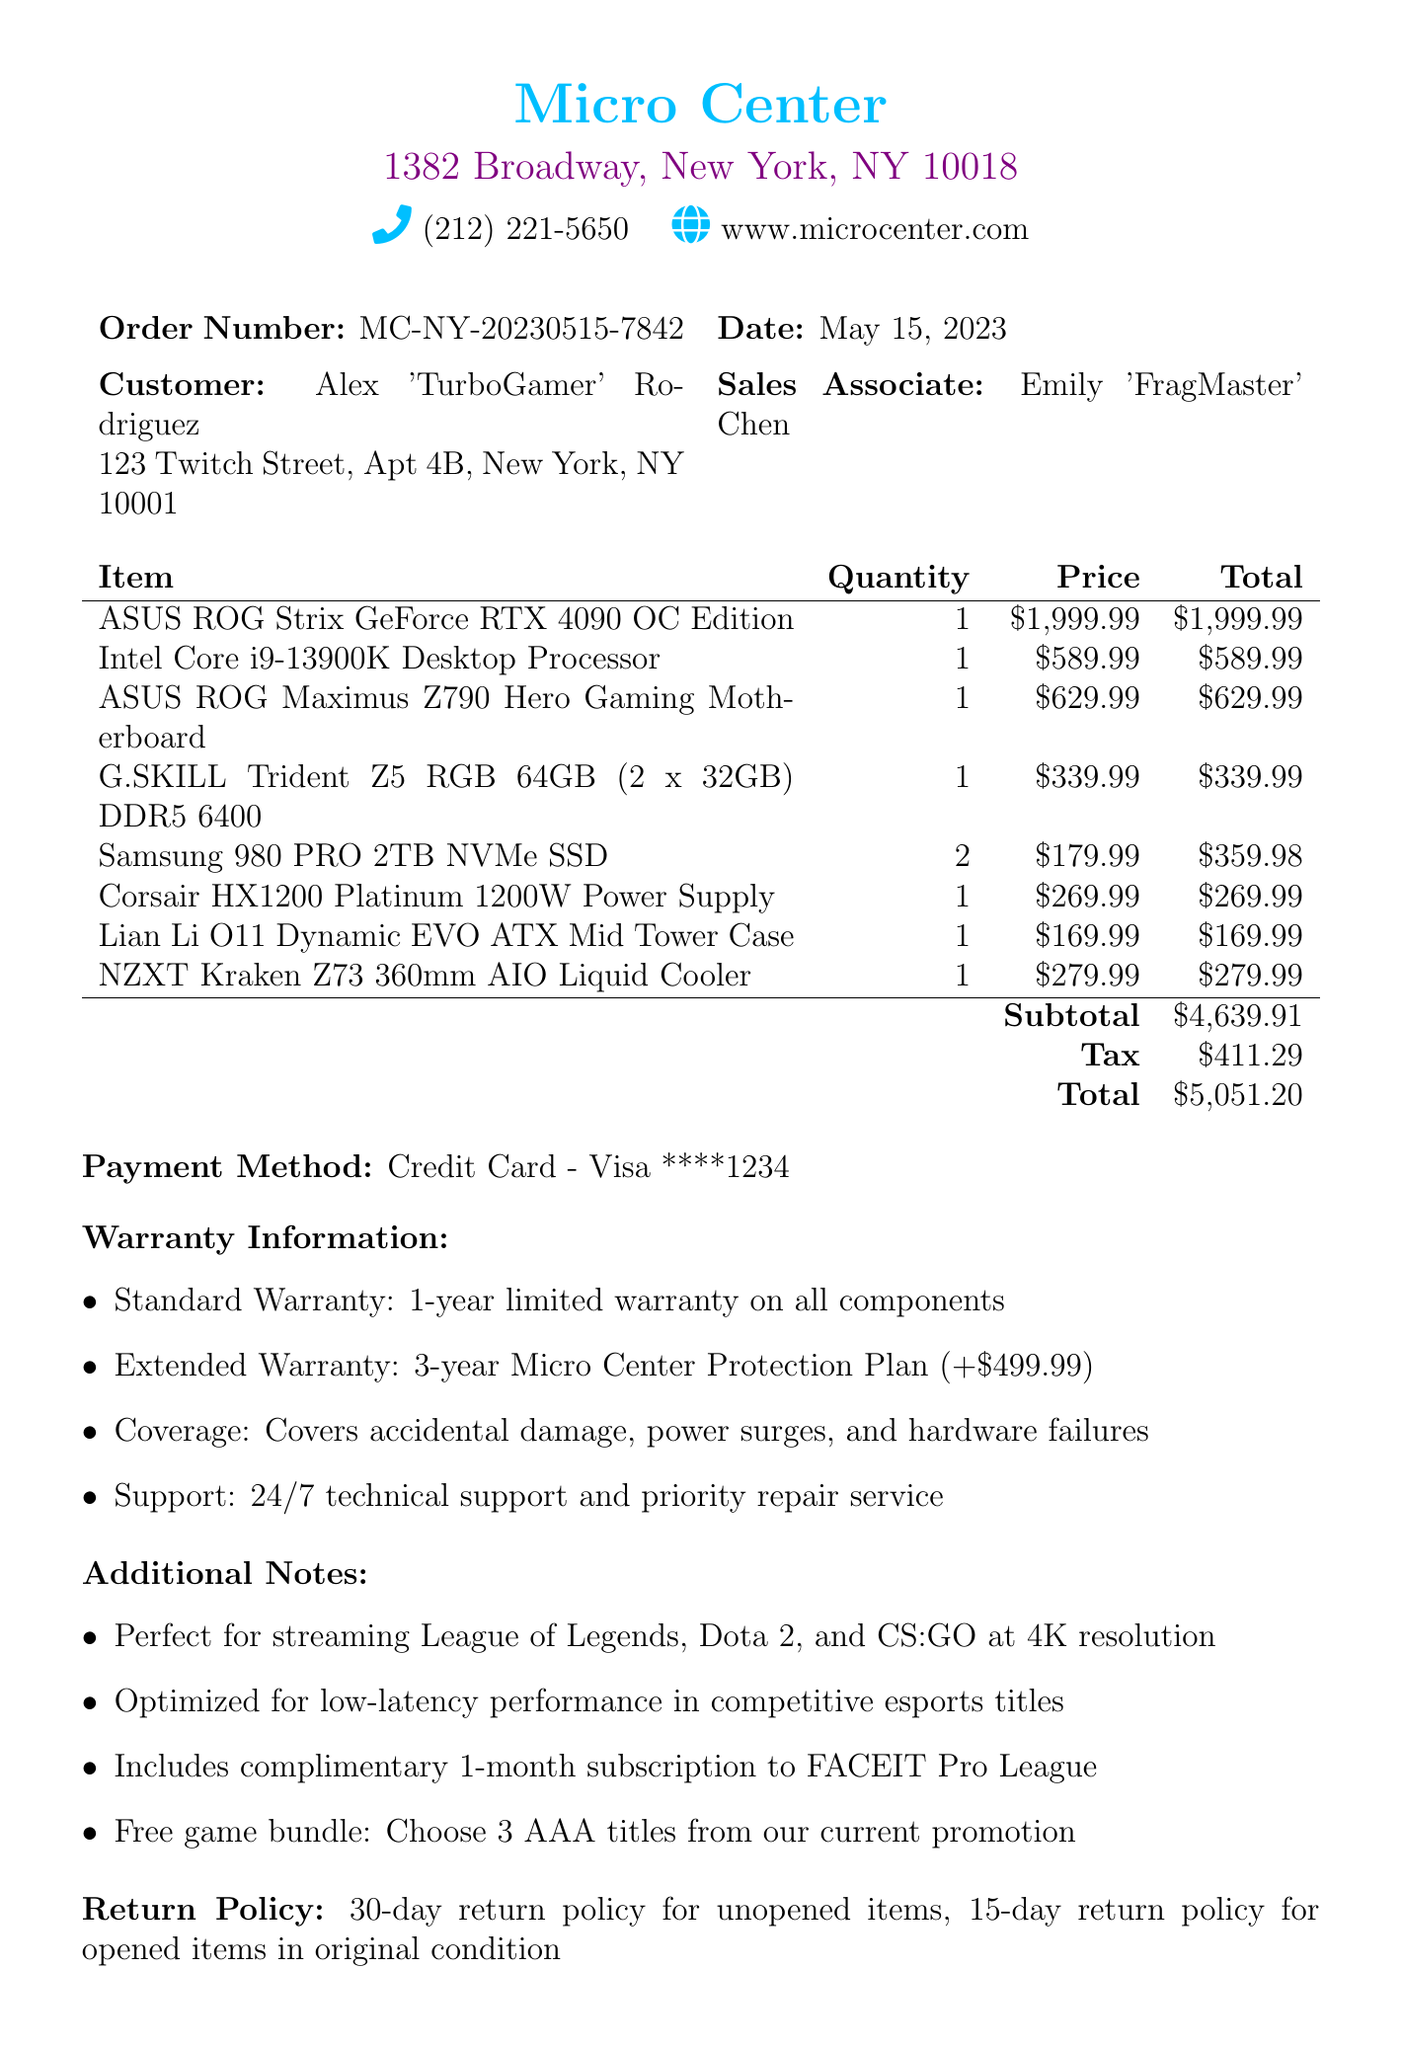What is the name of the store? The name of the store is mentioned at the top of the document.
Answer: Micro Center Who made the purchase? The customer's name is specified along with the address in the document.
Answer: Alex 'TurboGamer' Rodriguez What is the order number? The order number is presented clearly in the document for tracking purposes.
Answer: MC-NY-20230515-7842 What is the date of the transaction? The date is listed next to the order number in the document header.
Answer: May 15, 2023 What is the subtotal amount? The subtotal amount is calculated by summing the prices of all items before tax.
Answer: $4639.91 What is the tax amount? The tax amount is shown separately in the document after the subtotal.
Answer: $411.29 What is the total cost? The total cost includes the subtotal and tax, as specified in the document.
Answer: $5051.20 What is included in the standard warranty? The document provides the details of the warranty coverage offered.
Answer: 1-year limited warranty on all components What is the return policy for opened items? The document explicitly states the return policy for opened items.
Answer: 15-day return policy for opened items in original condition What streaming games are mentioned? The document notes the capabilities of the purchased PC for specific games.
Answer: League of Legends, Dota 2, and CS:GO 